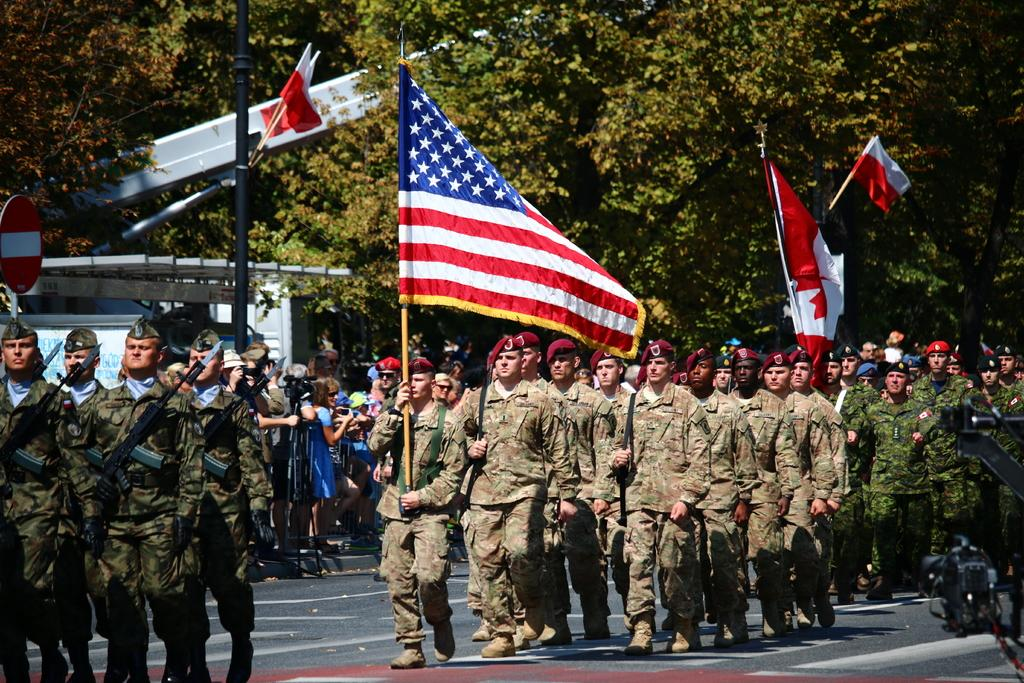What are the people in the image doing on the road? The people in the image are standing on the road. What objects are some of the people holding in their hands? Some of the people are holding flags and rifles in their hands. What can be seen in the background of the image? There are trees visible in the background of the image. What type of pigs can be seen playing in the snow in the image? There are no pigs or snow present in the image; it features people standing on the road with flags and rifles. 